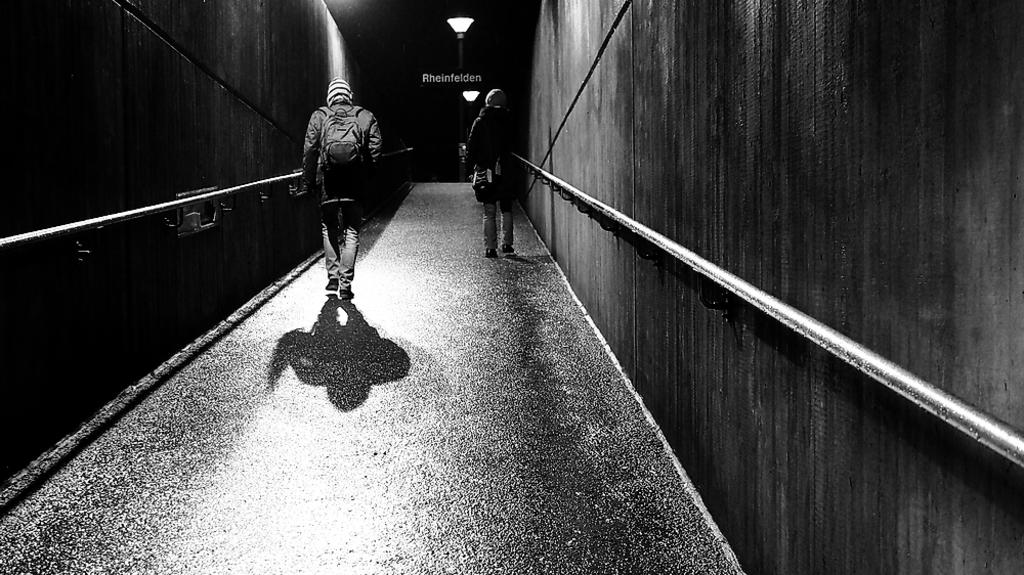Who or what is present in the image? There are people in the image. What are the people wearing? The people are wearing bags. What are the people doing in the image? The people are walking. What can be seen in the background of the image? There is a light and a wall in the background of the image. Can you tell me how many frogs are involved in the argument in the image? There is no argument or frogs present in the image; it features people walking while wearing bags. 